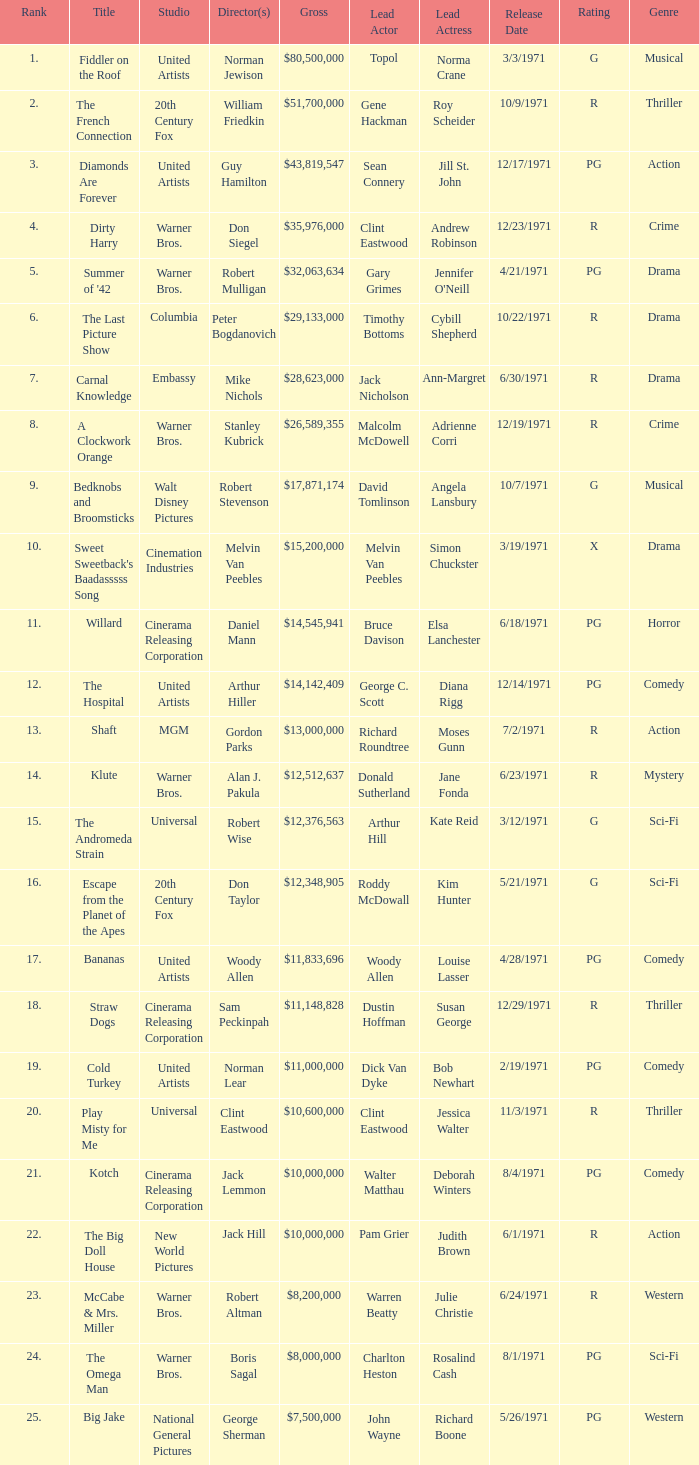What rank is the title with a gross of $26,589,355? 8.0. 